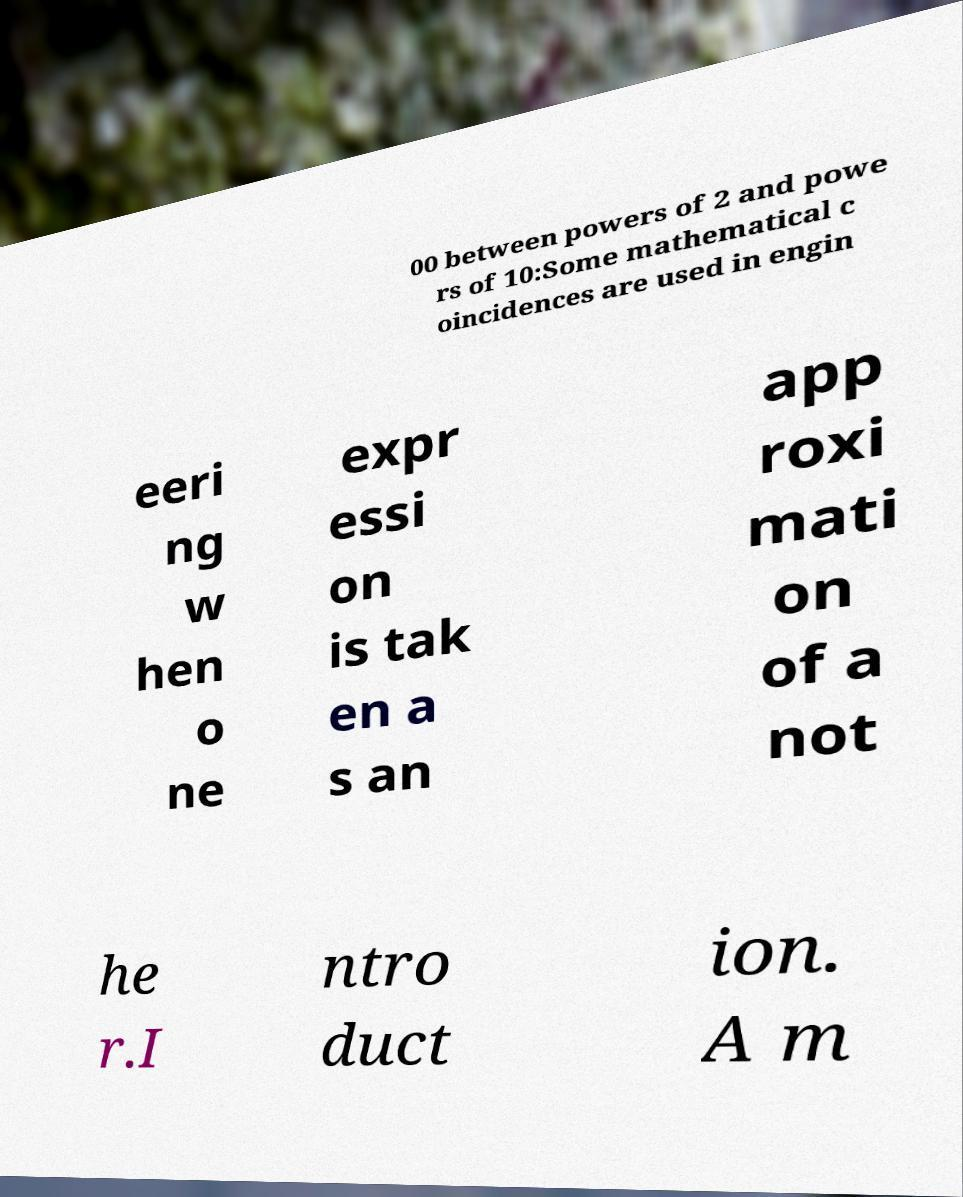Please read and relay the text visible in this image. What does it say? 00 between powers of 2 and powe rs of 10:Some mathematical c oincidences are used in engin eeri ng w hen o ne expr essi on is tak en a s an app roxi mati on of a not he r.I ntro duct ion. A m 